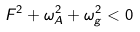<formula> <loc_0><loc_0><loc_500><loc_500>F ^ { 2 } + \omega _ { A } ^ { 2 } + \omega _ { g } ^ { 2 } < 0</formula> 